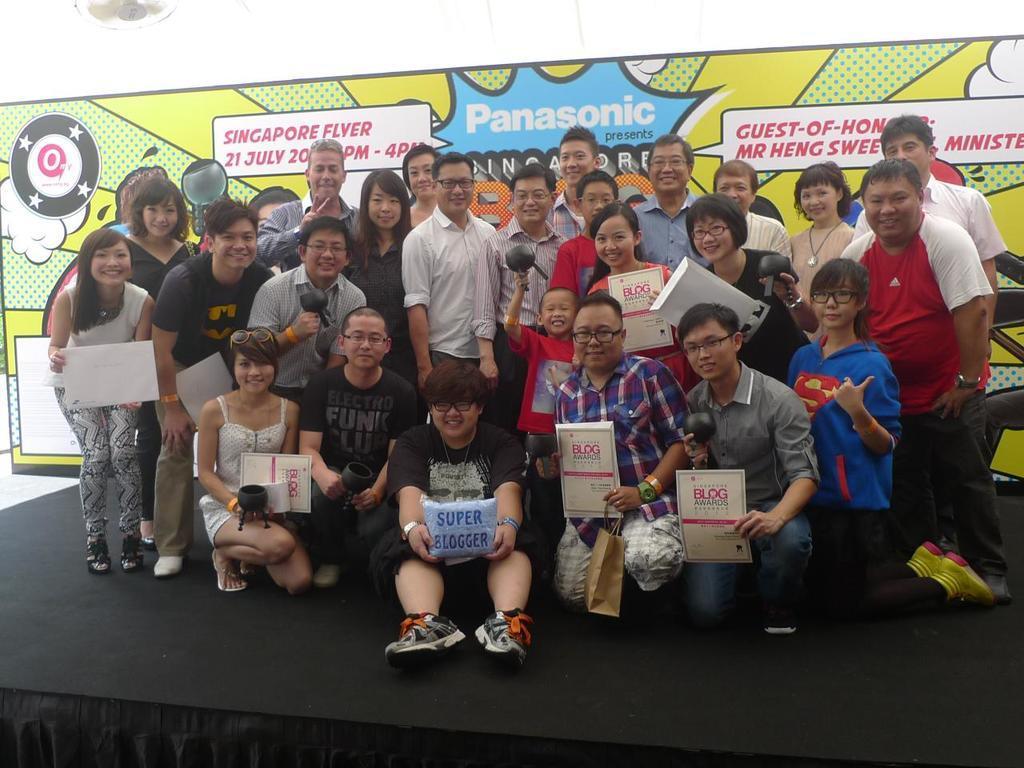In one or two sentences, can you explain what this image depicts? In this picture we can see a group of people on the stage and in the background we can see a poster. 